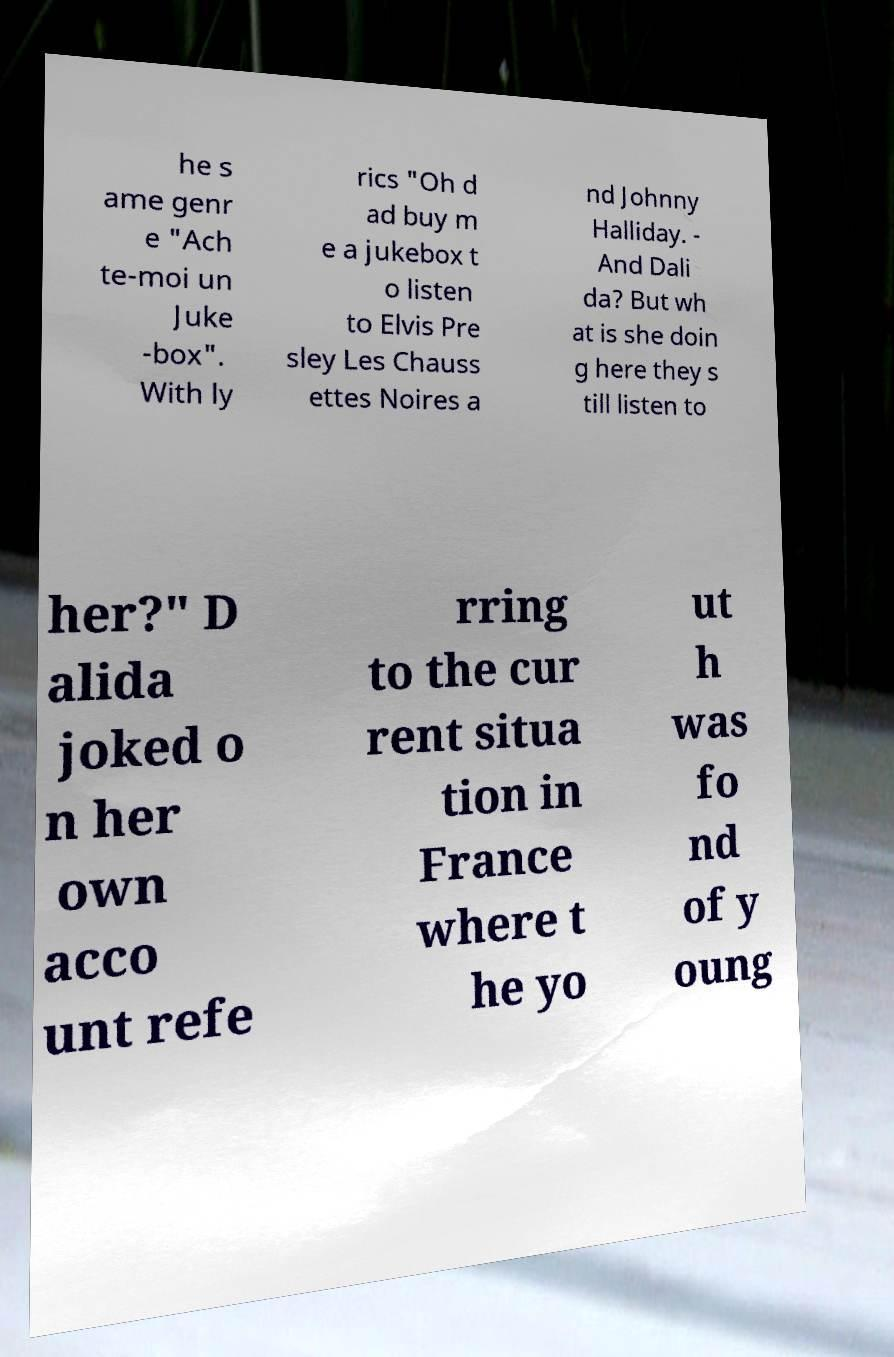Could you extract and type out the text from this image? he s ame genr e "Ach te-moi un Juke -box". With ly rics "Oh d ad buy m e a jukebox t o listen to Elvis Pre sley Les Chauss ettes Noires a nd Johnny Halliday. - And Dali da? But wh at is she doin g here they s till listen to her?" D alida joked o n her own acco unt refe rring to the cur rent situa tion in France where t he yo ut h was fo nd of y oung 